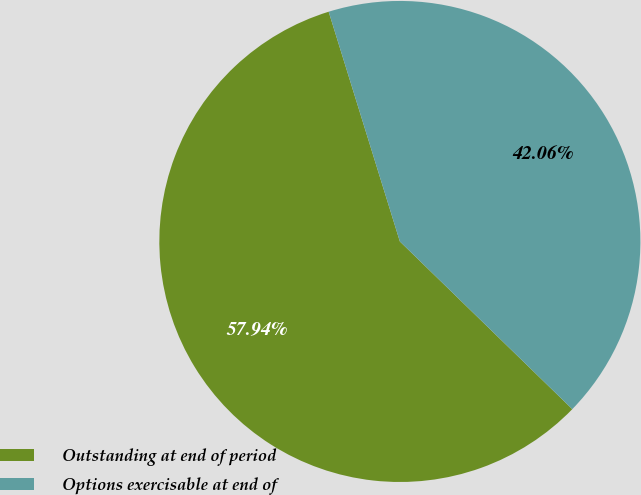Convert chart to OTSL. <chart><loc_0><loc_0><loc_500><loc_500><pie_chart><fcel>Outstanding at end of period<fcel>Options exercisable at end of<nl><fcel>57.94%<fcel>42.06%<nl></chart> 